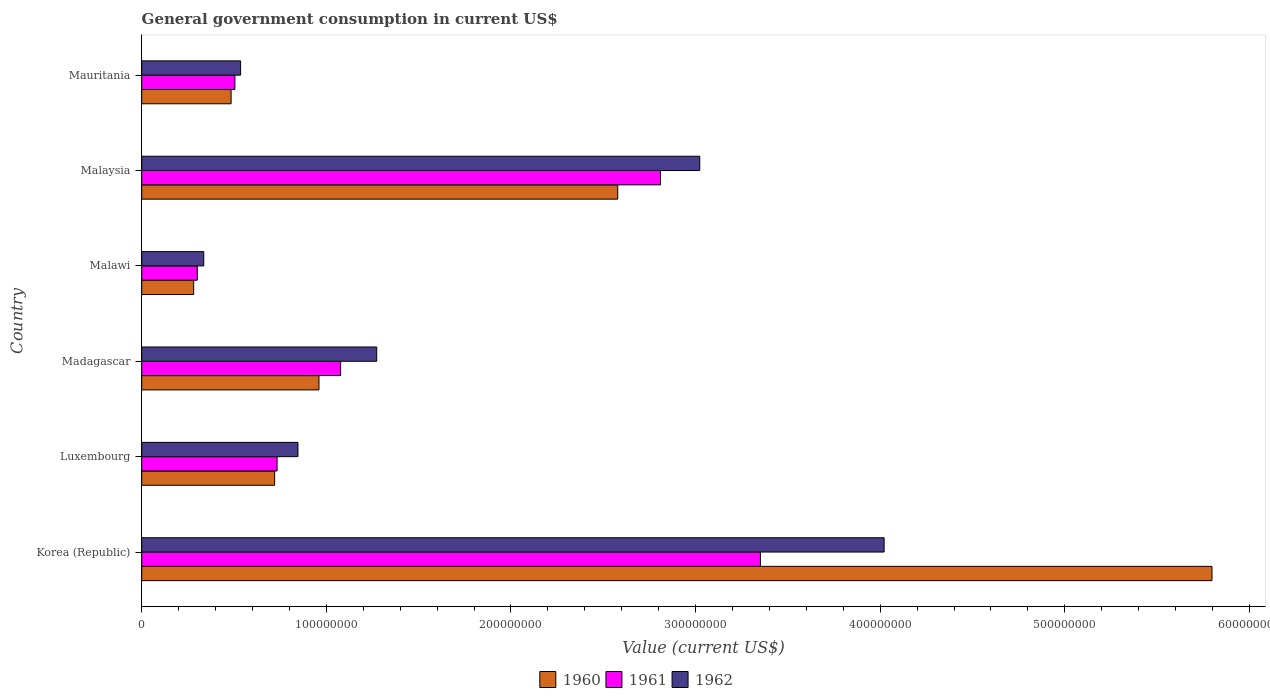How many different coloured bars are there?
Provide a succinct answer. 3. How many groups of bars are there?
Your response must be concise. 6. Are the number of bars on each tick of the Y-axis equal?
Your response must be concise. Yes. What is the label of the 3rd group of bars from the top?
Offer a very short reply. Malawi. What is the government conusmption in 1961 in Malaysia?
Provide a short and direct response. 2.81e+08. Across all countries, what is the maximum government conusmption in 1962?
Ensure brevity in your answer.  4.02e+08. Across all countries, what is the minimum government conusmption in 1961?
Ensure brevity in your answer.  3.01e+07. In which country was the government conusmption in 1960 maximum?
Your answer should be compact. Korea (Republic). In which country was the government conusmption in 1961 minimum?
Give a very brief answer. Malawi. What is the total government conusmption in 1960 in the graph?
Ensure brevity in your answer.  1.08e+09. What is the difference between the government conusmption in 1961 in Luxembourg and that in Malawi?
Offer a terse response. 4.32e+07. What is the difference between the government conusmption in 1960 in Malaysia and the government conusmption in 1962 in Mauritania?
Make the answer very short. 2.04e+08. What is the average government conusmption in 1961 per country?
Provide a succinct answer. 1.46e+08. What is the difference between the government conusmption in 1961 and government conusmption in 1962 in Malaysia?
Your answer should be compact. -2.12e+07. What is the ratio of the government conusmption in 1962 in Korea (Republic) to that in Madagascar?
Provide a short and direct response. 3.16. What is the difference between the highest and the second highest government conusmption in 1962?
Your answer should be compact. 9.99e+07. What is the difference between the highest and the lowest government conusmption in 1961?
Your answer should be very brief. 3.05e+08. In how many countries, is the government conusmption in 1961 greater than the average government conusmption in 1961 taken over all countries?
Provide a succinct answer. 2. What does the 3rd bar from the bottom in Mauritania represents?
Keep it short and to the point. 1962. Is it the case that in every country, the sum of the government conusmption in 1962 and government conusmption in 1961 is greater than the government conusmption in 1960?
Provide a succinct answer. Yes. How many countries are there in the graph?
Your answer should be very brief. 6. What is the difference between two consecutive major ticks on the X-axis?
Ensure brevity in your answer.  1.00e+08. Are the values on the major ticks of X-axis written in scientific E-notation?
Offer a terse response. No. Does the graph contain any zero values?
Offer a terse response. No. How are the legend labels stacked?
Give a very brief answer. Horizontal. What is the title of the graph?
Your response must be concise. General government consumption in current US$. Does "1982" appear as one of the legend labels in the graph?
Ensure brevity in your answer.  No. What is the label or title of the X-axis?
Keep it short and to the point. Value (current US$). What is the Value (current US$) of 1960 in Korea (Republic)?
Your answer should be very brief. 5.80e+08. What is the Value (current US$) of 1961 in Korea (Republic)?
Ensure brevity in your answer.  3.35e+08. What is the Value (current US$) in 1962 in Korea (Republic)?
Keep it short and to the point. 4.02e+08. What is the Value (current US$) of 1960 in Luxembourg?
Your answer should be compact. 7.20e+07. What is the Value (current US$) in 1961 in Luxembourg?
Offer a terse response. 7.33e+07. What is the Value (current US$) in 1962 in Luxembourg?
Make the answer very short. 8.46e+07. What is the Value (current US$) of 1960 in Madagascar?
Your answer should be very brief. 9.60e+07. What is the Value (current US$) in 1961 in Madagascar?
Ensure brevity in your answer.  1.08e+08. What is the Value (current US$) of 1962 in Madagascar?
Provide a succinct answer. 1.27e+08. What is the Value (current US$) of 1960 in Malawi?
Give a very brief answer. 2.81e+07. What is the Value (current US$) of 1961 in Malawi?
Keep it short and to the point. 3.01e+07. What is the Value (current US$) of 1962 in Malawi?
Provide a short and direct response. 3.36e+07. What is the Value (current US$) of 1960 in Malaysia?
Give a very brief answer. 2.58e+08. What is the Value (current US$) of 1961 in Malaysia?
Provide a short and direct response. 2.81e+08. What is the Value (current US$) in 1962 in Malaysia?
Make the answer very short. 3.02e+08. What is the Value (current US$) of 1960 in Mauritania?
Keep it short and to the point. 4.84e+07. What is the Value (current US$) of 1961 in Mauritania?
Offer a very short reply. 5.05e+07. What is the Value (current US$) of 1962 in Mauritania?
Your answer should be very brief. 5.36e+07. Across all countries, what is the maximum Value (current US$) of 1960?
Offer a very short reply. 5.80e+08. Across all countries, what is the maximum Value (current US$) of 1961?
Give a very brief answer. 3.35e+08. Across all countries, what is the maximum Value (current US$) in 1962?
Provide a short and direct response. 4.02e+08. Across all countries, what is the minimum Value (current US$) in 1960?
Make the answer very short. 2.81e+07. Across all countries, what is the minimum Value (current US$) in 1961?
Offer a very short reply. 3.01e+07. Across all countries, what is the minimum Value (current US$) in 1962?
Provide a short and direct response. 3.36e+07. What is the total Value (current US$) of 1960 in the graph?
Give a very brief answer. 1.08e+09. What is the total Value (current US$) of 1961 in the graph?
Keep it short and to the point. 8.78e+08. What is the total Value (current US$) in 1962 in the graph?
Ensure brevity in your answer.  1.00e+09. What is the difference between the Value (current US$) of 1960 in Korea (Republic) and that in Luxembourg?
Offer a very short reply. 5.08e+08. What is the difference between the Value (current US$) in 1961 in Korea (Republic) and that in Luxembourg?
Ensure brevity in your answer.  2.62e+08. What is the difference between the Value (current US$) in 1962 in Korea (Republic) and that in Luxembourg?
Provide a short and direct response. 3.17e+08. What is the difference between the Value (current US$) in 1960 in Korea (Republic) and that in Madagascar?
Provide a short and direct response. 4.84e+08. What is the difference between the Value (current US$) in 1961 in Korea (Republic) and that in Madagascar?
Give a very brief answer. 2.27e+08. What is the difference between the Value (current US$) in 1962 in Korea (Republic) and that in Madagascar?
Provide a short and direct response. 2.75e+08. What is the difference between the Value (current US$) of 1960 in Korea (Republic) and that in Malawi?
Offer a terse response. 5.52e+08. What is the difference between the Value (current US$) of 1961 in Korea (Republic) and that in Malawi?
Provide a short and direct response. 3.05e+08. What is the difference between the Value (current US$) in 1962 in Korea (Republic) and that in Malawi?
Provide a short and direct response. 3.69e+08. What is the difference between the Value (current US$) of 1960 in Korea (Republic) and that in Malaysia?
Your response must be concise. 3.22e+08. What is the difference between the Value (current US$) in 1961 in Korea (Republic) and that in Malaysia?
Your answer should be compact. 5.41e+07. What is the difference between the Value (current US$) of 1962 in Korea (Republic) and that in Malaysia?
Provide a succinct answer. 9.99e+07. What is the difference between the Value (current US$) in 1960 in Korea (Republic) and that in Mauritania?
Ensure brevity in your answer.  5.31e+08. What is the difference between the Value (current US$) of 1961 in Korea (Republic) and that in Mauritania?
Provide a succinct answer. 2.85e+08. What is the difference between the Value (current US$) of 1962 in Korea (Republic) and that in Mauritania?
Make the answer very short. 3.49e+08. What is the difference between the Value (current US$) in 1960 in Luxembourg and that in Madagascar?
Your response must be concise. -2.40e+07. What is the difference between the Value (current US$) in 1961 in Luxembourg and that in Madagascar?
Keep it short and to the point. -3.44e+07. What is the difference between the Value (current US$) of 1962 in Luxembourg and that in Madagascar?
Offer a very short reply. -4.27e+07. What is the difference between the Value (current US$) in 1960 in Luxembourg and that in Malawi?
Keep it short and to the point. 4.38e+07. What is the difference between the Value (current US$) of 1961 in Luxembourg and that in Malawi?
Your response must be concise. 4.32e+07. What is the difference between the Value (current US$) of 1962 in Luxembourg and that in Malawi?
Your response must be concise. 5.10e+07. What is the difference between the Value (current US$) of 1960 in Luxembourg and that in Malaysia?
Give a very brief answer. -1.86e+08. What is the difference between the Value (current US$) in 1961 in Luxembourg and that in Malaysia?
Keep it short and to the point. -2.08e+08. What is the difference between the Value (current US$) of 1962 in Luxembourg and that in Malaysia?
Provide a succinct answer. -2.18e+08. What is the difference between the Value (current US$) in 1960 in Luxembourg and that in Mauritania?
Offer a very short reply. 2.36e+07. What is the difference between the Value (current US$) of 1961 in Luxembourg and that in Mauritania?
Ensure brevity in your answer.  2.28e+07. What is the difference between the Value (current US$) of 1962 in Luxembourg and that in Mauritania?
Offer a terse response. 3.11e+07. What is the difference between the Value (current US$) in 1960 in Madagascar and that in Malawi?
Keep it short and to the point. 6.79e+07. What is the difference between the Value (current US$) in 1961 in Madagascar and that in Malawi?
Provide a succinct answer. 7.76e+07. What is the difference between the Value (current US$) in 1962 in Madagascar and that in Malawi?
Your answer should be compact. 9.37e+07. What is the difference between the Value (current US$) of 1960 in Madagascar and that in Malaysia?
Provide a short and direct response. -1.62e+08. What is the difference between the Value (current US$) in 1961 in Madagascar and that in Malaysia?
Provide a succinct answer. -1.73e+08. What is the difference between the Value (current US$) in 1962 in Madagascar and that in Malaysia?
Offer a terse response. -1.75e+08. What is the difference between the Value (current US$) of 1960 in Madagascar and that in Mauritania?
Provide a succinct answer. 4.76e+07. What is the difference between the Value (current US$) of 1961 in Madagascar and that in Mauritania?
Make the answer very short. 5.73e+07. What is the difference between the Value (current US$) in 1962 in Madagascar and that in Mauritania?
Make the answer very short. 7.37e+07. What is the difference between the Value (current US$) in 1960 in Malawi and that in Malaysia?
Provide a short and direct response. -2.30e+08. What is the difference between the Value (current US$) in 1961 in Malawi and that in Malaysia?
Offer a terse response. -2.51e+08. What is the difference between the Value (current US$) in 1962 in Malawi and that in Malaysia?
Give a very brief answer. -2.69e+08. What is the difference between the Value (current US$) in 1960 in Malawi and that in Mauritania?
Your answer should be compact. -2.03e+07. What is the difference between the Value (current US$) in 1961 in Malawi and that in Mauritania?
Your answer should be very brief. -2.04e+07. What is the difference between the Value (current US$) of 1962 in Malawi and that in Mauritania?
Give a very brief answer. -2.00e+07. What is the difference between the Value (current US$) of 1960 in Malaysia and that in Mauritania?
Offer a very short reply. 2.09e+08. What is the difference between the Value (current US$) of 1961 in Malaysia and that in Mauritania?
Your answer should be compact. 2.31e+08. What is the difference between the Value (current US$) in 1962 in Malaysia and that in Mauritania?
Your answer should be very brief. 2.49e+08. What is the difference between the Value (current US$) of 1960 in Korea (Republic) and the Value (current US$) of 1961 in Luxembourg?
Ensure brevity in your answer.  5.06e+08. What is the difference between the Value (current US$) of 1960 in Korea (Republic) and the Value (current US$) of 1962 in Luxembourg?
Your answer should be compact. 4.95e+08. What is the difference between the Value (current US$) in 1961 in Korea (Republic) and the Value (current US$) in 1962 in Luxembourg?
Provide a short and direct response. 2.51e+08. What is the difference between the Value (current US$) in 1960 in Korea (Republic) and the Value (current US$) in 1961 in Madagascar?
Provide a succinct answer. 4.72e+08. What is the difference between the Value (current US$) in 1960 in Korea (Republic) and the Value (current US$) in 1962 in Madagascar?
Ensure brevity in your answer.  4.52e+08. What is the difference between the Value (current US$) of 1961 in Korea (Republic) and the Value (current US$) of 1962 in Madagascar?
Your answer should be compact. 2.08e+08. What is the difference between the Value (current US$) of 1960 in Korea (Republic) and the Value (current US$) of 1961 in Malawi?
Your answer should be very brief. 5.50e+08. What is the difference between the Value (current US$) in 1960 in Korea (Republic) and the Value (current US$) in 1962 in Malawi?
Offer a very short reply. 5.46e+08. What is the difference between the Value (current US$) of 1961 in Korea (Republic) and the Value (current US$) of 1962 in Malawi?
Your answer should be compact. 3.02e+08. What is the difference between the Value (current US$) in 1960 in Korea (Republic) and the Value (current US$) in 1961 in Malaysia?
Keep it short and to the point. 2.99e+08. What is the difference between the Value (current US$) of 1960 in Korea (Republic) and the Value (current US$) of 1962 in Malaysia?
Provide a short and direct response. 2.77e+08. What is the difference between the Value (current US$) in 1961 in Korea (Republic) and the Value (current US$) in 1962 in Malaysia?
Ensure brevity in your answer.  3.29e+07. What is the difference between the Value (current US$) of 1960 in Korea (Republic) and the Value (current US$) of 1961 in Mauritania?
Provide a succinct answer. 5.29e+08. What is the difference between the Value (current US$) in 1960 in Korea (Republic) and the Value (current US$) in 1962 in Mauritania?
Give a very brief answer. 5.26e+08. What is the difference between the Value (current US$) of 1961 in Korea (Republic) and the Value (current US$) of 1962 in Mauritania?
Your response must be concise. 2.82e+08. What is the difference between the Value (current US$) in 1960 in Luxembourg and the Value (current US$) in 1961 in Madagascar?
Your answer should be compact. -3.58e+07. What is the difference between the Value (current US$) of 1960 in Luxembourg and the Value (current US$) of 1962 in Madagascar?
Keep it short and to the point. -5.53e+07. What is the difference between the Value (current US$) of 1961 in Luxembourg and the Value (current US$) of 1962 in Madagascar?
Make the answer very short. -5.40e+07. What is the difference between the Value (current US$) in 1960 in Luxembourg and the Value (current US$) in 1961 in Malawi?
Offer a very short reply. 4.19e+07. What is the difference between the Value (current US$) of 1960 in Luxembourg and the Value (current US$) of 1962 in Malawi?
Give a very brief answer. 3.84e+07. What is the difference between the Value (current US$) of 1961 in Luxembourg and the Value (current US$) of 1962 in Malawi?
Your response must be concise. 3.97e+07. What is the difference between the Value (current US$) of 1960 in Luxembourg and the Value (current US$) of 1961 in Malaysia?
Ensure brevity in your answer.  -2.09e+08. What is the difference between the Value (current US$) of 1960 in Luxembourg and the Value (current US$) of 1962 in Malaysia?
Provide a short and direct response. -2.30e+08. What is the difference between the Value (current US$) in 1961 in Luxembourg and the Value (current US$) in 1962 in Malaysia?
Keep it short and to the point. -2.29e+08. What is the difference between the Value (current US$) in 1960 in Luxembourg and the Value (current US$) in 1961 in Mauritania?
Offer a very short reply. 2.15e+07. What is the difference between the Value (current US$) of 1960 in Luxembourg and the Value (current US$) of 1962 in Mauritania?
Provide a succinct answer. 1.84e+07. What is the difference between the Value (current US$) in 1961 in Luxembourg and the Value (current US$) in 1962 in Mauritania?
Your response must be concise. 1.97e+07. What is the difference between the Value (current US$) in 1960 in Madagascar and the Value (current US$) in 1961 in Malawi?
Provide a short and direct response. 6.59e+07. What is the difference between the Value (current US$) of 1960 in Madagascar and the Value (current US$) of 1962 in Malawi?
Offer a very short reply. 6.24e+07. What is the difference between the Value (current US$) of 1961 in Madagascar and the Value (current US$) of 1962 in Malawi?
Your answer should be compact. 7.41e+07. What is the difference between the Value (current US$) in 1960 in Madagascar and the Value (current US$) in 1961 in Malaysia?
Offer a terse response. -1.85e+08. What is the difference between the Value (current US$) in 1960 in Madagascar and the Value (current US$) in 1962 in Malaysia?
Make the answer very short. -2.06e+08. What is the difference between the Value (current US$) of 1961 in Madagascar and the Value (current US$) of 1962 in Malaysia?
Keep it short and to the point. -1.95e+08. What is the difference between the Value (current US$) of 1960 in Madagascar and the Value (current US$) of 1961 in Mauritania?
Provide a succinct answer. 4.55e+07. What is the difference between the Value (current US$) of 1960 in Madagascar and the Value (current US$) of 1962 in Mauritania?
Offer a very short reply. 4.24e+07. What is the difference between the Value (current US$) in 1961 in Madagascar and the Value (current US$) in 1962 in Mauritania?
Your answer should be compact. 5.42e+07. What is the difference between the Value (current US$) of 1960 in Malawi and the Value (current US$) of 1961 in Malaysia?
Provide a short and direct response. -2.53e+08. What is the difference between the Value (current US$) of 1960 in Malawi and the Value (current US$) of 1962 in Malaysia?
Provide a short and direct response. -2.74e+08. What is the difference between the Value (current US$) of 1961 in Malawi and the Value (current US$) of 1962 in Malaysia?
Your answer should be very brief. -2.72e+08. What is the difference between the Value (current US$) in 1960 in Malawi and the Value (current US$) in 1961 in Mauritania?
Your response must be concise. -2.23e+07. What is the difference between the Value (current US$) in 1960 in Malawi and the Value (current US$) in 1962 in Mauritania?
Your answer should be compact. -2.54e+07. What is the difference between the Value (current US$) in 1961 in Malawi and the Value (current US$) in 1962 in Mauritania?
Provide a succinct answer. -2.35e+07. What is the difference between the Value (current US$) in 1960 in Malaysia and the Value (current US$) in 1961 in Mauritania?
Offer a very short reply. 2.07e+08. What is the difference between the Value (current US$) of 1960 in Malaysia and the Value (current US$) of 1962 in Mauritania?
Keep it short and to the point. 2.04e+08. What is the difference between the Value (current US$) of 1961 in Malaysia and the Value (current US$) of 1962 in Mauritania?
Provide a succinct answer. 2.27e+08. What is the average Value (current US$) in 1960 per country?
Offer a terse response. 1.80e+08. What is the average Value (current US$) of 1961 per country?
Provide a succinct answer. 1.46e+08. What is the average Value (current US$) in 1962 per country?
Ensure brevity in your answer.  1.67e+08. What is the difference between the Value (current US$) of 1960 and Value (current US$) of 1961 in Korea (Republic)?
Provide a short and direct response. 2.45e+08. What is the difference between the Value (current US$) of 1960 and Value (current US$) of 1962 in Korea (Republic)?
Offer a very short reply. 1.78e+08. What is the difference between the Value (current US$) in 1961 and Value (current US$) in 1962 in Korea (Republic)?
Your answer should be compact. -6.70e+07. What is the difference between the Value (current US$) of 1960 and Value (current US$) of 1961 in Luxembourg?
Your answer should be compact. -1.33e+06. What is the difference between the Value (current US$) of 1960 and Value (current US$) of 1962 in Luxembourg?
Give a very brief answer. -1.26e+07. What is the difference between the Value (current US$) of 1961 and Value (current US$) of 1962 in Luxembourg?
Make the answer very short. -1.13e+07. What is the difference between the Value (current US$) in 1960 and Value (current US$) in 1961 in Madagascar?
Provide a succinct answer. -1.17e+07. What is the difference between the Value (current US$) of 1960 and Value (current US$) of 1962 in Madagascar?
Your response must be concise. -3.13e+07. What is the difference between the Value (current US$) in 1961 and Value (current US$) in 1962 in Madagascar?
Provide a short and direct response. -1.96e+07. What is the difference between the Value (current US$) of 1960 and Value (current US$) of 1961 in Malawi?
Keep it short and to the point. -1.96e+06. What is the difference between the Value (current US$) in 1960 and Value (current US$) in 1962 in Malawi?
Keep it short and to the point. -5.46e+06. What is the difference between the Value (current US$) of 1961 and Value (current US$) of 1962 in Malawi?
Offer a very short reply. -3.50e+06. What is the difference between the Value (current US$) of 1960 and Value (current US$) of 1961 in Malaysia?
Your answer should be very brief. -2.32e+07. What is the difference between the Value (current US$) of 1960 and Value (current US$) of 1962 in Malaysia?
Your answer should be compact. -4.44e+07. What is the difference between the Value (current US$) of 1961 and Value (current US$) of 1962 in Malaysia?
Offer a terse response. -2.12e+07. What is the difference between the Value (current US$) in 1960 and Value (current US$) in 1961 in Mauritania?
Your answer should be compact. -2.06e+06. What is the difference between the Value (current US$) of 1960 and Value (current US$) of 1962 in Mauritania?
Your answer should be very brief. -5.15e+06. What is the difference between the Value (current US$) of 1961 and Value (current US$) of 1962 in Mauritania?
Ensure brevity in your answer.  -3.09e+06. What is the ratio of the Value (current US$) of 1960 in Korea (Republic) to that in Luxembourg?
Keep it short and to the point. 8.05. What is the ratio of the Value (current US$) of 1961 in Korea (Republic) to that in Luxembourg?
Make the answer very short. 4.57. What is the ratio of the Value (current US$) in 1962 in Korea (Republic) to that in Luxembourg?
Offer a very short reply. 4.75. What is the ratio of the Value (current US$) in 1960 in Korea (Republic) to that in Madagascar?
Your answer should be compact. 6.04. What is the ratio of the Value (current US$) in 1961 in Korea (Republic) to that in Madagascar?
Your response must be concise. 3.11. What is the ratio of the Value (current US$) in 1962 in Korea (Republic) to that in Madagascar?
Offer a terse response. 3.16. What is the ratio of the Value (current US$) in 1960 in Korea (Republic) to that in Malawi?
Offer a very short reply. 20.6. What is the ratio of the Value (current US$) of 1961 in Korea (Republic) to that in Malawi?
Your answer should be very brief. 11.13. What is the ratio of the Value (current US$) of 1962 in Korea (Republic) to that in Malawi?
Provide a succinct answer. 11.97. What is the ratio of the Value (current US$) of 1960 in Korea (Republic) to that in Malaysia?
Give a very brief answer. 2.25. What is the ratio of the Value (current US$) of 1961 in Korea (Republic) to that in Malaysia?
Give a very brief answer. 1.19. What is the ratio of the Value (current US$) in 1962 in Korea (Republic) to that in Malaysia?
Offer a very short reply. 1.33. What is the ratio of the Value (current US$) in 1960 in Korea (Republic) to that in Mauritania?
Your answer should be compact. 11.97. What is the ratio of the Value (current US$) of 1961 in Korea (Republic) to that in Mauritania?
Your response must be concise. 6.64. What is the ratio of the Value (current US$) in 1962 in Korea (Republic) to that in Mauritania?
Offer a terse response. 7.51. What is the ratio of the Value (current US$) in 1960 in Luxembourg to that in Madagascar?
Your response must be concise. 0.75. What is the ratio of the Value (current US$) in 1961 in Luxembourg to that in Madagascar?
Offer a terse response. 0.68. What is the ratio of the Value (current US$) in 1962 in Luxembourg to that in Madagascar?
Keep it short and to the point. 0.66. What is the ratio of the Value (current US$) in 1960 in Luxembourg to that in Malawi?
Your response must be concise. 2.56. What is the ratio of the Value (current US$) of 1961 in Luxembourg to that in Malawi?
Offer a very short reply. 2.44. What is the ratio of the Value (current US$) of 1962 in Luxembourg to that in Malawi?
Make the answer very short. 2.52. What is the ratio of the Value (current US$) in 1960 in Luxembourg to that in Malaysia?
Ensure brevity in your answer.  0.28. What is the ratio of the Value (current US$) of 1961 in Luxembourg to that in Malaysia?
Your answer should be compact. 0.26. What is the ratio of the Value (current US$) in 1962 in Luxembourg to that in Malaysia?
Your response must be concise. 0.28. What is the ratio of the Value (current US$) in 1960 in Luxembourg to that in Mauritania?
Ensure brevity in your answer.  1.49. What is the ratio of the Value (current US$) of 1961 in Luxembourg to that in Mauritania?
Give a very brief answer. 1.45. What is the ratio of the Value (current US$) in 1962 in Luxembourg to that in Mauritania?
Give a very brief answer. 1.58. What is the ratio of the Value (current US$) in 1960 in Madagascar to that in Malawi?
Offer a terse response. 3.41. What is the ratio of the Value (current US$) of 1961 in Madagascar to that in Malawi?
Offer a very short reply. 3.58. What is the ratio of the Value (current US$) of 1962 in Madagascar to that in Malawi?
Give a very brief answer. 3.79. What is the ratio of the Value (current US$) in 1960 in Madagascar to that in Malaysia?
Offer a very short reply. 0.37. What is the ratio of the Value (current US$) in 1961 in Madagascar to that in Malaysia?
Make the answer very short. 0.38. What is the ratio of the Value (current US$) in 1962 in Madagascar to that in Malaysia?
Your response must be concise. 0.42. What is the ratio of the Value (current US$) in 1960 in Madagascar to that in Mauritania?
Keep it short and to the point. 1.98. What is the ratio of the Value (current US$) of 1961 in Madagascar to that in Mauritania?
Provide a short and direct response. 2.13. What is the ratio of the Value (current US$) of 1962 in Madagascar to that in Mauritania?
Offer a very short reply. 2.38. What is the ratio of the Value (current US$) in 1960 in Malawi to that in Malaysia?
Provide a succinct answer. 0.11. What is the ratio of the Value (current US$) in 1961 in Malawi to that in Malaysia?
Offer a terse response. 0.11. What is the ratio of the Value (current US$) in 1962 in Malawi to that in Malaysia?
Offer a very short reply. 0.11. What is the ratio of the Value (current US$) of 1960 in Malawi to that in Mauritania?
Give a very brief answer. 0.58. What is the ratio of the Value (current US$) in 1961 in Malawi to that in Mauritania?
Ensure brevity in your answer.  0.6. What is the ratio of the Value (current US$) of 1962 in Malawi to that in Mauritania?
Give a very brief answer. 0.63. What is the ratio of the Value (current US$) in 1960 in Malaysia to that in Mauritania?
Keep it short and to the point. 5.33. What is the ratio of the Value (current US$) of 1961 in Malaysia to that in Mauritania?
Give a very brief answer. 5.57. What is the ratio of the Value (current US$) of 1962 in Malaysia to that in Mauritania?
Make the answer very short. 5.64. What is the difference between the highest and the second highest Value (current US$) of 1960?
Provide a succinct answer. 3.22e+08. What is the difference between the highest and the second highest Value (current US$) in 1961?
Offer a very short reply. 5.41e+07. What is the difference between the highest and the second highest Value (current US$) of 1962?
Keep it short and to the point. 9.99e+07. What is the difference between the highest and the lowest Value (current US$) in 1960?
Your answer should be compact. 5.52e+08. What is the difference between the highest and the lowest Value (current US$) in 1961?
Your answer should be very brief. 3.05e+08. What is the difference between the highest and the lowest Value (current US$) in 1962?
Offer a very short reply. 3.69e+08. 